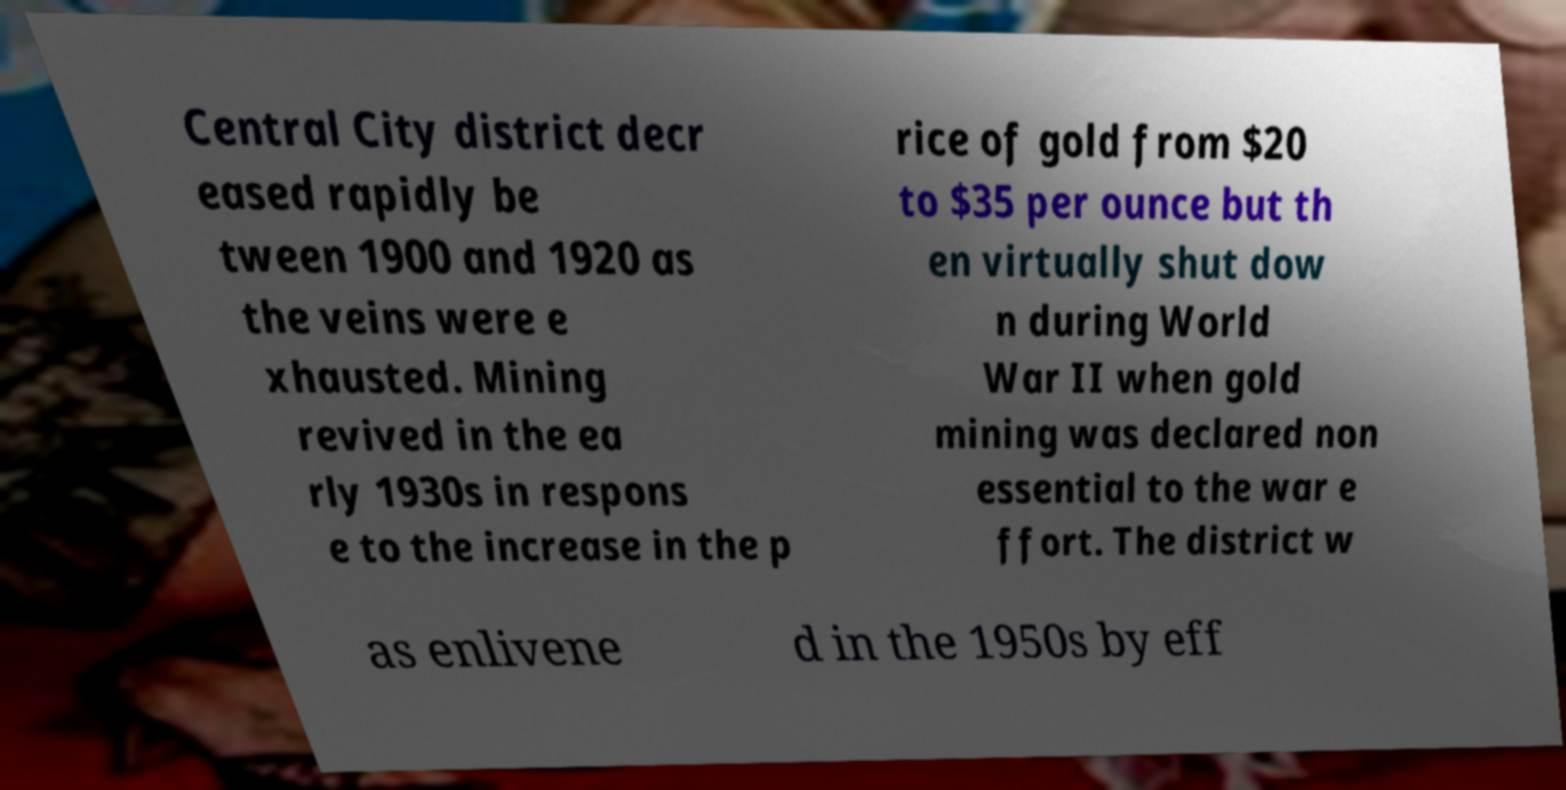Could you extract and type out the text from this image? Central City district decr eased rapidly be tween 1900 and 1920 as the veins were e xhausted. Mining revived in the ea rly 1930s in respons e to the increase in the p rice of gold from $20 to $35 per ounce but th en virtually shut dow n during World War II when gold mining was declared non essential to the war e ffort. The district w as enlivene d in the 1950s by eff 